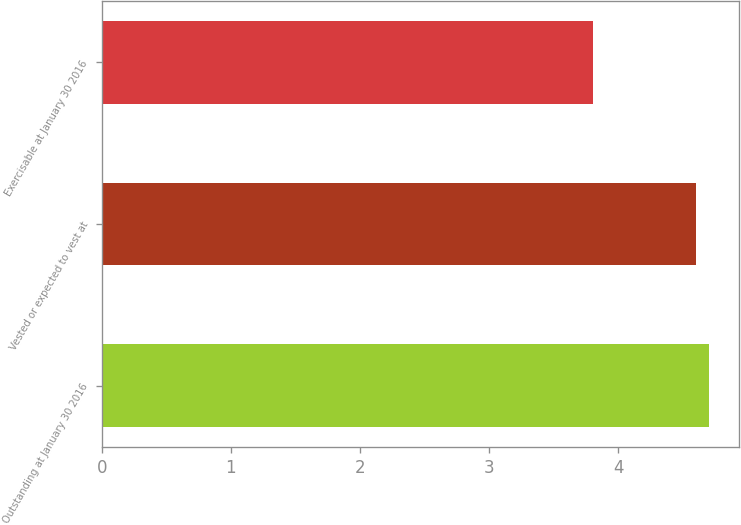Convert chart. <chart><loc_0><loc_0><loc_500><loc_500><bar_chart><fcel>Outstanding at January 30 2016<fcel>Vested or expected to vest at<fcel>Exercisable at January 30 2016<nl><fcel>4.7<fcel>4.6<fcel>3.8<nl></chart> 